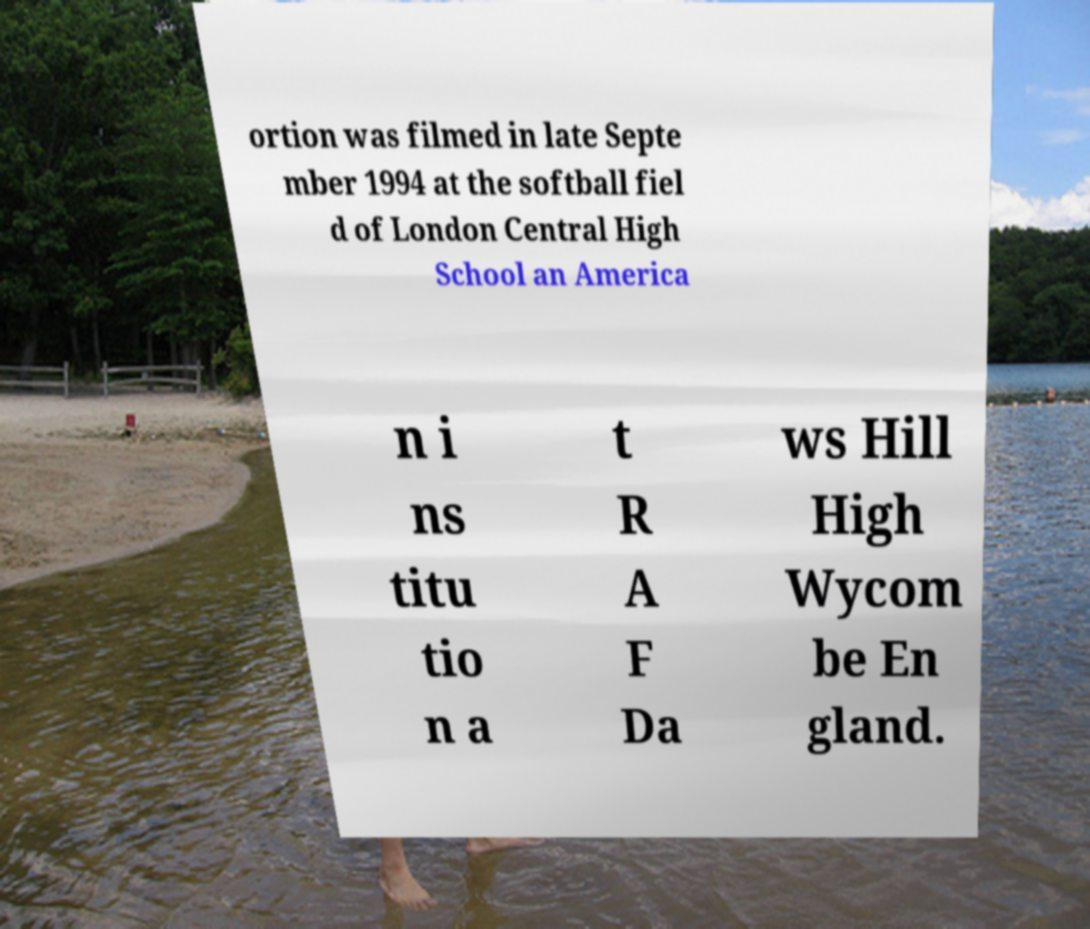Please read and relay the text visible in this image. What does it say? ortion was filmed in late Septe mber 1994 at the softball fiel d of London Central High School an America n i ns titu tio n a t R A F Da ws Hill High Wycom be En gland. 